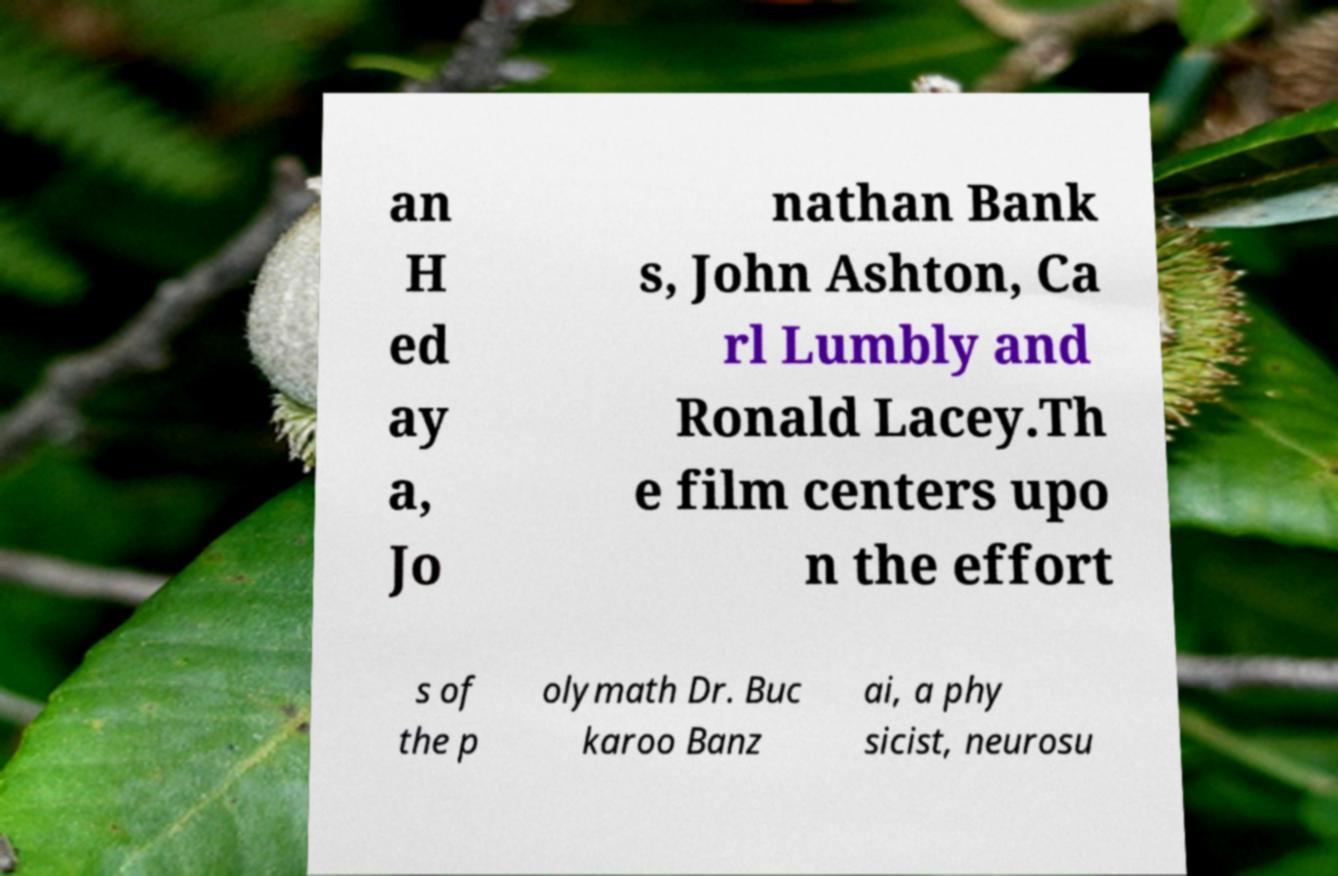Please identify and transcribe the text found in this image. an H ed ay a, Jo nathan Bank s, John Ashton, Ca rl Lumbly and Ronald Lacey.Th e film centers upo n the effort s of the p olymath Dr. Buc karoo Banz ai, a phy sicist, neurosu 